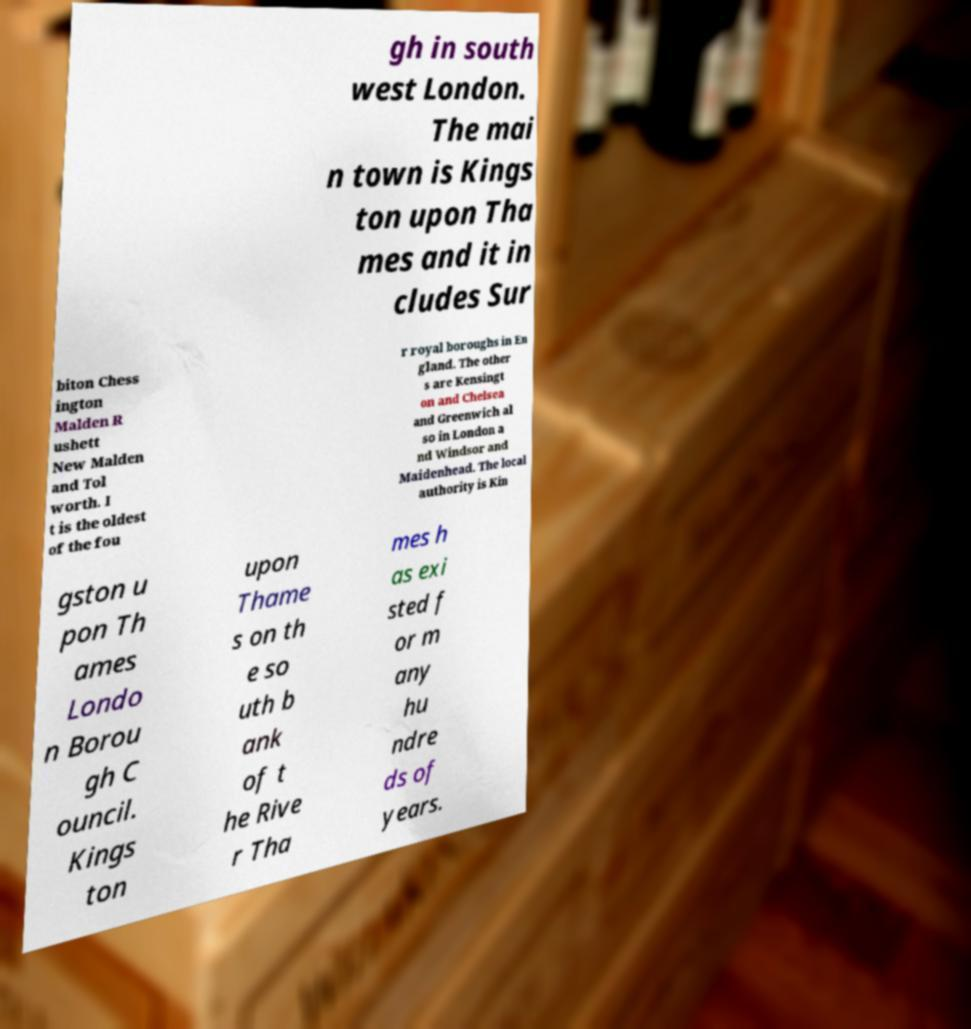Could you extract and type out the text from this image? gh in south west London. The mai n town is Kings ton upon Tha mes and it in cludes Sur biton Chess ington Malden R ushett New Malden and Tol worth. I t is the oldest of the fou r royal boroughs in En gland. The other s are Kensingt on and Chelsea and Greenwich al so in London a nd Windsor and Maidenhead. The local authority is Kin gston u pon Th ames Londo n Borou gh C ouncil. Kings ton upon Thame s on th e so uth b ank of t he Rive r Tha mes h as exi sted f or m any hu ndre ds of years. 